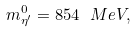Convert formula to latex. <formula><loc_0><loc_0><loc_500><loc_500>m ^ { 0 } _ { \eta ^ { \prime } } = 8 5 4 \ M e V ,</formula> 